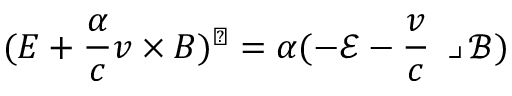Convert formula to latex. <formula><loc_0><loc_0><loc_500><loc_500>( E + \frac { \alpha } { c } v \times B ) ^ { \flat } = \alpha ( - \ m a t h s c r { E } - \frac { v } { c } \lrcorner \ m a t h s c r { B } )</formula> 